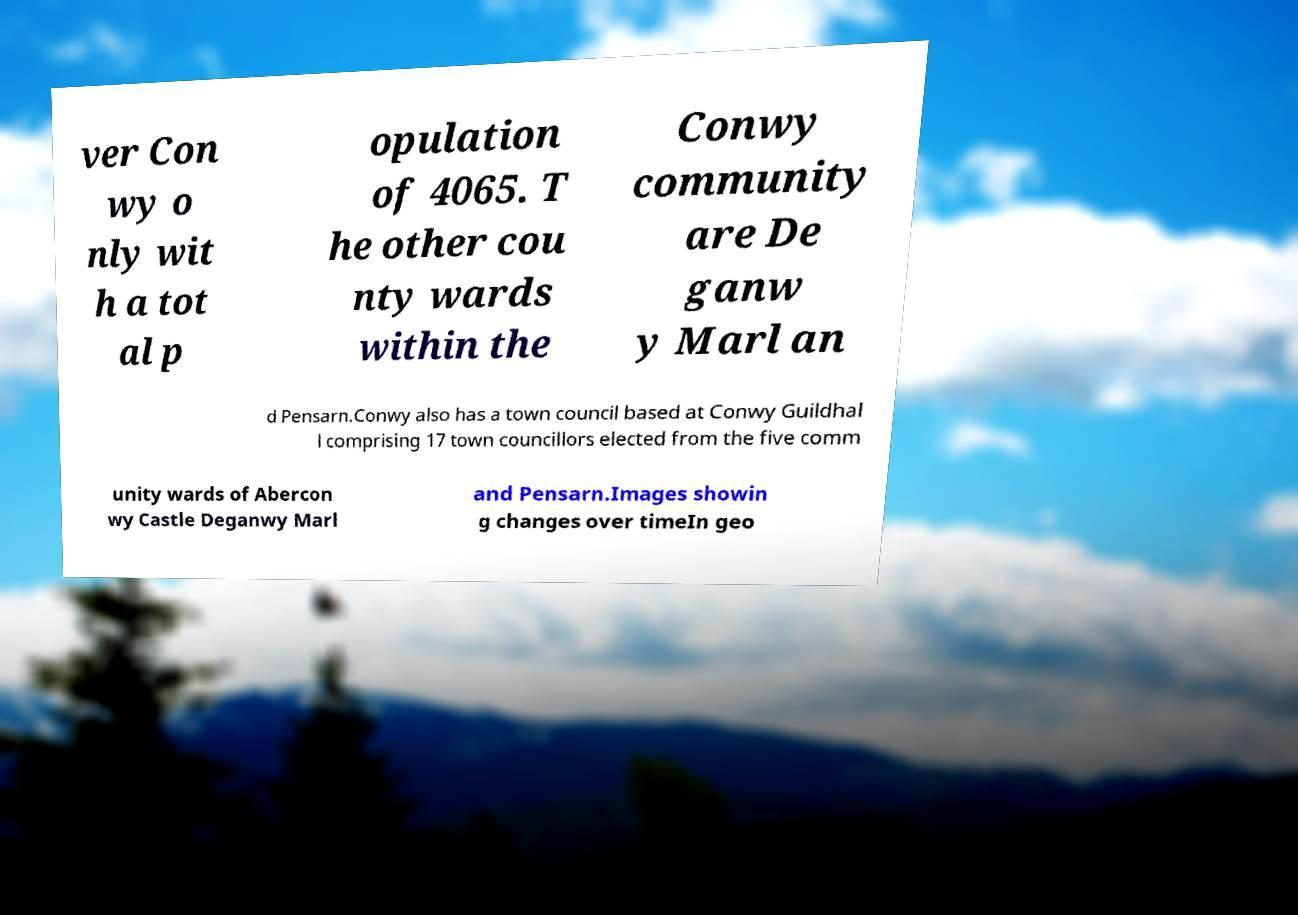Could you assist in decoding the text presented in this image and type it out clearly? ver Con wy o nly wit h a tot al p opulation of 4065. T he other cou nty wards within the Conwy community are De ganw y Marl an d Pensarn.Conwy also has a town council based at Conwy Guildhal l comprising 17 town councillors elected from the five comm unity wards of Abercon wy Castle Deganwy Marl and Pensarn.Images showin g changes over timeIn geo 